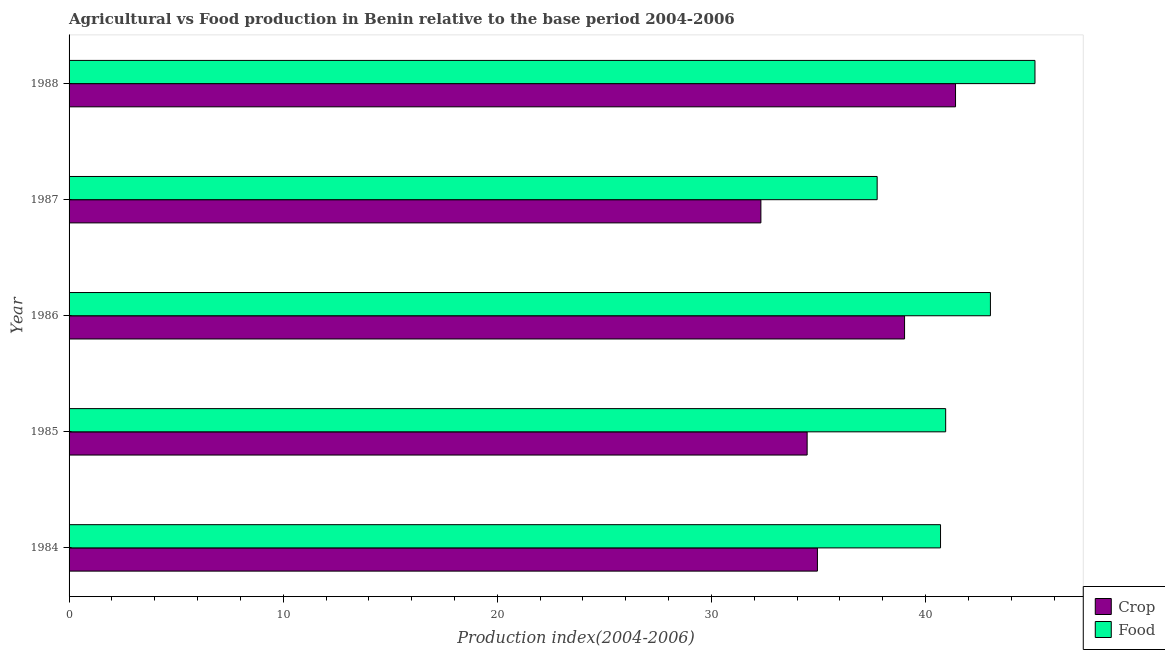How many different coloured bars are there?
Your answer should be compact. 2. How many groups of bars are there?
Provide a short and direct response. 5. Are the number of bars per tick equal to the number of legend labels?
Offer a terse response. Yes. Are the number of bars on each tick of the Y-axis equal?
Make the answer very short. Yes. How many bars are there on the 5th tick from the top?
Ensure brevity in your answer.  2. How many bars are there on the 4th tick from the bottom?
Offer a terse response. 2. In how many cases, is the number of bars for a given year not equal to the number of legend labels?
Give a very brief answer. 0. What is the crop production index in 1985?
Give a very brief answer. 34.47. Across all years, what is the maximum crop production index?
Provide a succinct answer. 41.4. Across all years, what is the minimum food production index?
Ensure brevity in your answer.  37.74. In which year was the crop production index maximum?
Offer a terse response. 1988. In which year was the crop production index minimum?
Your answer should be very brief. 1987. What is the total crop production index in the graph?
Offer a very short reply. 182.15. What is the difference between the crop production index in 1984 and that in 1987?
Your answer should be very brief. 2.64. What is the difference between the crop production index in 1987 and the food production index in 1985?
Ensure brevity in your answer.  -8.63. What is the average crop production index per year?
Give a very brief answer. 36.43. In the year 1986, what is the difference between the crop production index and food production index?
Give a very brief answer. -4.01. In how many years, is the food production index greater than 34 ?
Make the answer very short. 5. What is the ratio of the crop production index in 1984 to that in 1986?
Keep it short and to the point. 0.9. Is the difference between the food production index in 1984 and 1988 greater than the difference between the crop production index in 1984 and 1988?
Your response must be concise. Yes. What is the difference between the highest and the second highest crop production index?
Keep it short and to the point. 2.38. What is the difference between the highest and the lowest food production index?
Your answer should be very brief. 7.37. In how many years, is the crop production index greater than the average crop production index taken over all years?
Your answer should be very brief. 2. What does the 1st bar from the top in 1986 represents?
Keep it short and to the point. Food. What does the 2nd bar from the bottom in 1984 represents?
Your answer should be compact. Food. What is the difference between two consecutive major ticks on the X-axis?
Offer a very short reply. 10. Does the graph contain grids?
Provide a succinct answer. No. What is the title of the graph?
Give a very brief answer. Agricultural vs Food production in Benin relative to the base period 2004-2006. What is the label or title of the X-axis?
Your answer should be compact. Production index(2004-2006). What is the Production index(2004-2006) of Crop in 1984?
Give a very brief answer. 34.95. What is the Production index(2004-2006) of Food in 1984?
Your answer should be very brief. 40.7. What is the Production index(2004-2006) of Crop in 1985?
Give a very brief answer. 34.47. What is the Production index(2004-2006) in Food in 1985?
Ensure brevity in your answer.  40.94. What is the Production index(2004-2006) of Crop in 1986?
Provide a short and direct response. 39.02. What is the Production index(2004-2006) in Food in 1986?
Make the answer very short. 43.03. What is the Production index(2004-2006) in Crop in 1987?
Provide a short and direct response. 32.31. What is the Production index(2004-2006) in Food in 1987?
Ensure brevity in your answer.  37.74. What is the Production index(2004-2006) in Crop in 1988?
Give a very brief answer. 41.4. What is the Production index(2004-2006) of Food in 1988?
Give a very brief answer. 45.11. Across all years, what is the maximum Production index(2004-2006) of Crop?
Offer a terse response. 41.4. Across all years, what is the maximum Production index(2004-2006) in Food?
Provide a succinct answer. 45.11. Across all years, what is the minimum Production index(2004-2006) of Crop?
Provide a short and direct response. 32.31. Across all years, what is the minimum Production index(2004-2006) of Food?
Give a very brief answer. 37.74. What is the total Production index(2004-2006) in Crop in the graph?
Keep it short and to the point. 182.15. What is the total Production index(2004-2006) in Food in the graph?
Offer a terse response. 207.52. What is the difference between the Production index(2004-2006) of Crop in 1984 and that in 1985?
Provide a succinct answer. 0.48. What is the difference between the Production index(2004-2006) in Food in 1984 and that in 1985?
Give a very brief answer. -0.24. What is the difference between the Production index(2004-2006) of Crop in 1984 and that in 1986?
Give a very brief answer. -4.07. What is the difference between the Production index(2004-2006) in Food in 1984 and that in 1986?
Your response must be concise. -2.33. What is the difference between the Production index(2004-2006) in Crop in 1984 and that in 1987?
Make the answer very short. 2.64. What is the difference between the Production index(2004-2006) in Food in 1984 and that in 1987?
Give a very brief answer. 2.96. What is the difference between the Production index(2004-2006) of Crop in 1984 and that in 1988?
Your response must be concise. -6.45. What is the difference between the Production index(2004-2006) in Food in 1984 and that in 1988?
Offer a very short reply. -4.41. What is the difference between the Production index(2004-2006) of Crop in 1985 and that in 1986?
Keep it short and to the point. -4.55. What is the difference between the Production index(2004-2006) in Food in 1985 and that in 1986?
Provide a succinct answer. -2.09. What is the difference between the Production index(2004-2006) in Crop in 1985 and that in 1987?
Your answer should be compact. 2.16. What is the difference between the Production index(2004-2006) of Food in 1985 and that in 1987?
Your answer should be compact. 3.2. What is the difference between the Production index(2004-2006) in Crop in 1985 and that in 1988?
Provide a succinct answer. -6.93. What is the difference between the Production index(2004-2006) in Food in 1985 and that in 1988?
Make the answer very short. -4.17. What is the difference between the Production index(2004-2006) of Crop in 1986 and that in 1987?
Provide a short and direct response. 6.71. What is the difference between the Production index(2004-2006) of Food in 1986 and that in 1987?
Your answer should be compact. 5.29. What is the difference between the Production index(2004-2006) of Crop in 1986 and that in 1988?
Provide a succinct answer. -2.38. What is the difference between the Production index(2004-2006) in Food in 1986 and that in 1988?
Provide a succinct answer. -2.08. What is the difference between the Production index(2004-2006) in Crop in 1987 and that in 1988?
Ensure brevity in your answer.  -9.09. What is the difference between the Production index(2004-2006) of Food in 1987 and that in 1988?
Make the answer very short. -7.37. What is the difference between the Production index(2004-2006) of Crop in 1984 and the Production index(2004-2006) of Food in 1985?
Give a very brief answer. -5.99. What is the difference between the Production index(2004-2006) of Crop in 1984 and the Production index(2004-2006) of Food in 1986?
Offer a very short reply. -8.08. What is the difference between the Production index(2004-2006) of Crop in 1984 and the Production index(2004-2006) of Food in 1987?
Your response must be concise. -2.79. What is the difference between the Production index(2004-2006) in Crop in 1984 and the Production index(2004-2006) in Food in 1988?
Your answer should be compact. -10.16. What is the difference between the Production index(2004-2006) of Crop in 1985 and the Production index(2004-2006) of Food in 1986?
Give a very brief answer. -8.56. What is the difference between the Production index(2004-2006) of Crop in 1985 and the Production index(2004-2006) of Food in 1987?
Ensure brevity in your answer.  -3.27. What is the difference between the Production index(2004-2006) in Crop in 1985 and the Production index(2004-2006) in Food in 1988?
Provide a succinct answer. -10.64. What is the difference between the Production index(2004-2006) in Crop in 1986 and the Production index(2004-2006) in Food in 1987?
Offer a very short reply. 1.28. What is the difference between the Production index(2004-2006) of Crop in 1986 and the Production index(2004-2006) of Food in 1988?
Offer a very short reply. -6.09. What is the average Production index(2004-2006) in Crop per year?
Make the answer very short. 36.43. What is the average Production index(2004-2006) of Food per year?
Provide a short and direct response. 41.5. In the year 1984, what is the difference between the Production index(2004-2006) in Crop and Production index(2004-2006) in Food?
Provide a succinct answer. -5.75. In the year 1985, what is the difference between the Production index(2004-2006) of Crop and Production index(2004-2006) of Food?
Your answer should be very brief. -6.47. In the year 1986, what is the difference between the Production index(2004-2006) of Crop and Production index(2004-2006) of Food?
Keep it short and to the point. -4.01. In the year 1987, what is the difference between the Production index(2004-2006) in Crop and Production index(2004-2006) in Food?
Offer a terse response. -5.43. In the year 1988, what is the difference between the Production index(2004-2006) in Crop and Production index(2004-2006) in Food?
Offer a very short reply. -3.71. What is the ratio of the Production index(2004-2006) in Crop in 1984 to that in 1985?
Keep it short and to the point. 1.01. What is the ratio of the Production index(2004-2006) of Food in 1984 to that in 1985?
Your answer should be compact. 0.99. What is the ratio of the Production index(2004-2006) in Crop in 1984 to that in 1986?
Offer a terse response. 0.9. What is the ratio of the Production index(2004-2006) of Food in 1984 to that in 1986?
Provide a succinct answer. 0.95. What is the ratio of the Production index(2004-2006) in Crop in 1984 to that in 1987?
Provide a succinct answer. 1.08. What is the ratio of the Production index(2004-2006) in Food in 1984 to that in 1987?
Keep it short and to the point. 1.08. What is the ratio of the Production index(2004-2006) of Crop in 1984 to that in 1988?
Make the answer very short. 0.84. What is the ratio of the Production index(2004-2006) of Food in 1984 to that in 1988?
Provide a succinct answer. 0.9. What is the ratio of the Production index(2004-2006) in Crop in 1985 to that in 1986?
Keep it short and to the point. 0.88. What is the ratio of the Production index(2004-2006) of Food in 1985 to that in 1986?
Your response must be concise. 0.95. What is the ratio of the Production index(2004-2006) of Crop in 1985 to that in 1987?
Offer a very short reply. 1.07. What is the ratio of the Production index(2004-2006) of Food in 1985 to that in 1987?
Your response must be concise. 1.08. What is the ratio of the Production index(2004-2006) in Crop in 1985 to that in 1988?
Offer a very short reply. 0.83. What is the ratio of the Production index(2004-2006) in Food in 1985 to that in 1988?
Make the answer very short. 0.91. What is the ratio of the Production index(2004-2006) in Crop in 1986 to that in 1987?
Your response must be concise. 1.21. What is the ratio of the Production index(2004-2006) in Food in 1986 to that in 1987?
Give a very brief answer. 1.14. What is the ratio of the Production index(2004-2006) in Crop in 1986 to that in 1988?
Give a very brief answer. 0.94. What is the ratio of the Production index(2004-2006) in Food in 1986 to that in 1988?
Offer a terse response. 0.95. What is the ratio of the Production index(2004-2006) of Crop in 1987 to that in 1988?
Make the answer very short. 0.78. What is the ratio of the Production index(2004-2006) in Food in 1987 to that in 1988?
Keep it short and to the point. 0.84. What is the difference between the highest and the second highest Production index(2004-2006) of Crop?
Provide a short and direct response. 2.38. What is the difference between the highest and the second highest Production index(2004-2006) of Food?
Keep it short and to the point. 2.08. What is the difference between the highest and the lowest Production index(2004-2006) of Crop?
Give a very brief answer. 9.09. What is the difference between the highest and the lowest Production index(2004-2006) in Food?
Ensure brevity in your answer.  7.37. 